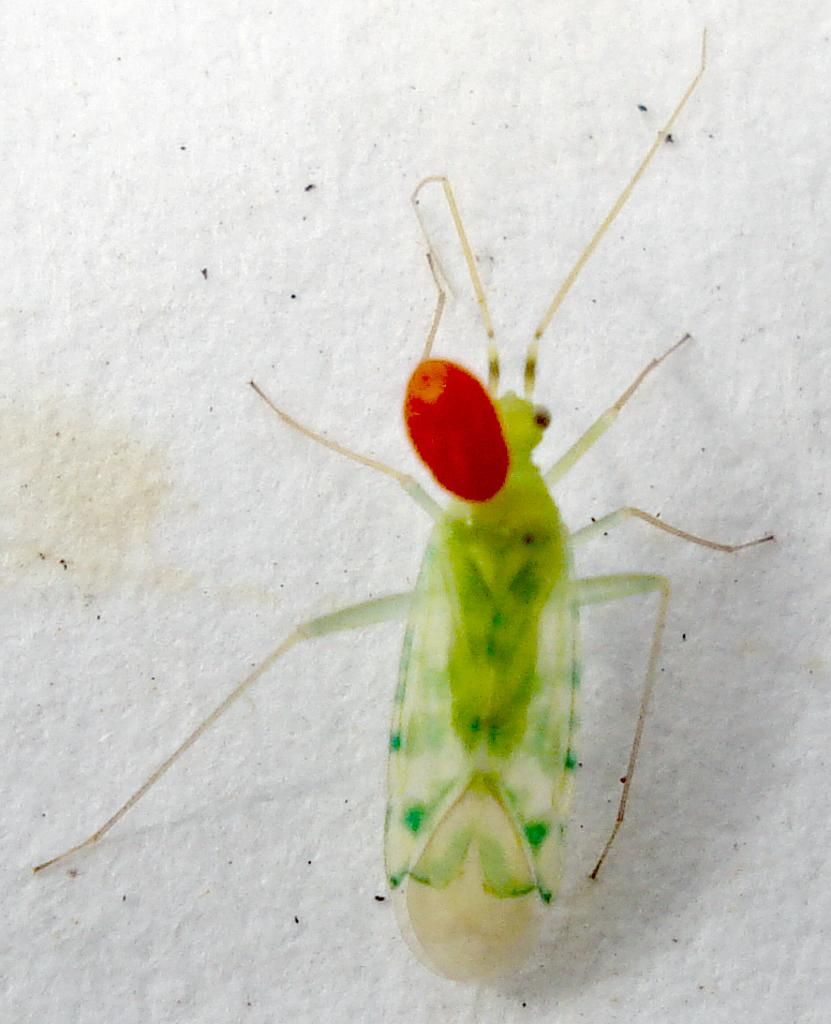What type of insect is present in the image? There is a cicada in the image. What type of kitty can be seen playing with the brake in the image? There is no kitty or brake present in the image; it features a cicada. How much dirt is visible on the cicada in the image? There is no dirt visible on the cicada in the image, as it is a clean insect. 